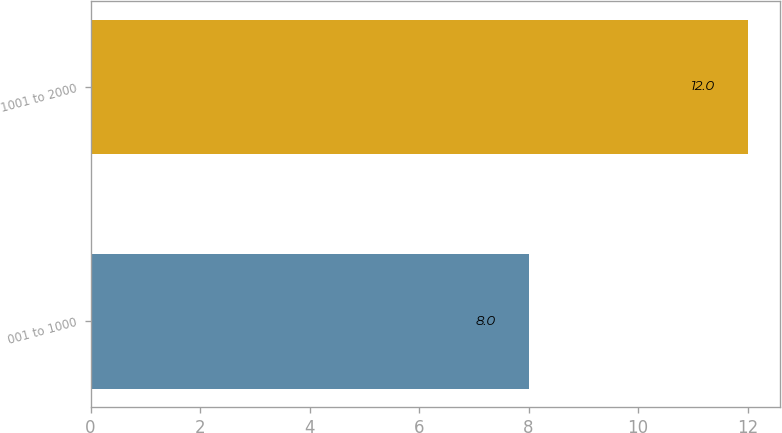Convert chart. <chart><loc_0><loc_0><loc_500><loc_500><bar_chart><fcel>001 to 1000<fcel>1001 to 2000<nl><fcel>8<fcel>12<nl></chart> 